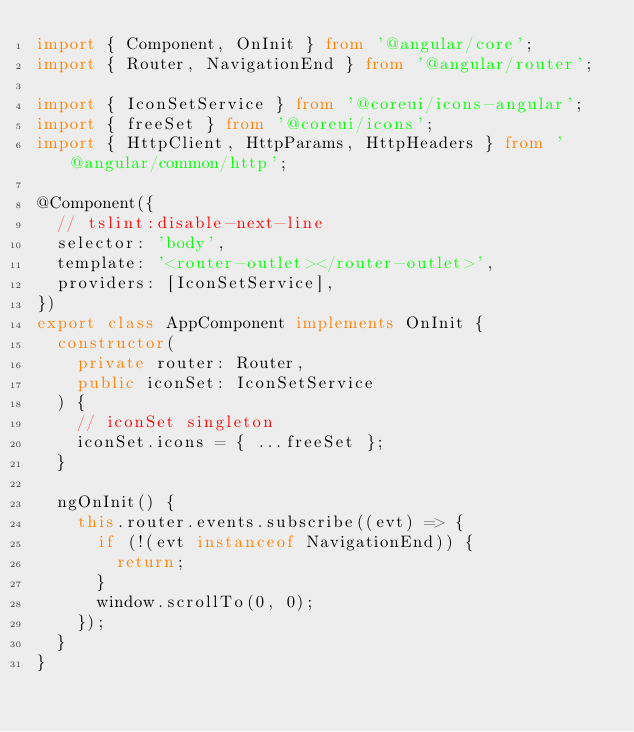Convert code to text. <code><loc_0><loc_0><loc_500><loc_500><_TypeScript_>import { Component, OnInit } from '@angular/core';
import { Router, NavigationEnd } from '@angular/router';

import { IconSetService } from '@coreui/icons-angular';
import { freeSet } from '@coreui/icons';
import { HttpClient, HttpParams, HttpHeaders } from '@angular/common/http';

@Component({
  // tslint:disable-next-line
  selector: 'body',
  template: '<router-outlet></router-outlet>',
  providers: [IconSetService],
})
export class AppComponent implements OnInit {
  constructor(
    private router: Router,
    public iconSet: IconSetService
  ) {
    // iconSet singleton
    iconSet.icons = { ...freeSet };
  }

  ngOnInit() {
    this.router.events.subscribe((evt) => {
      if (!(evt instanceof NavigationEnd)) {
        return;
      }
      window.scrollTo(0, 0);
    });
  }
}
</code> 